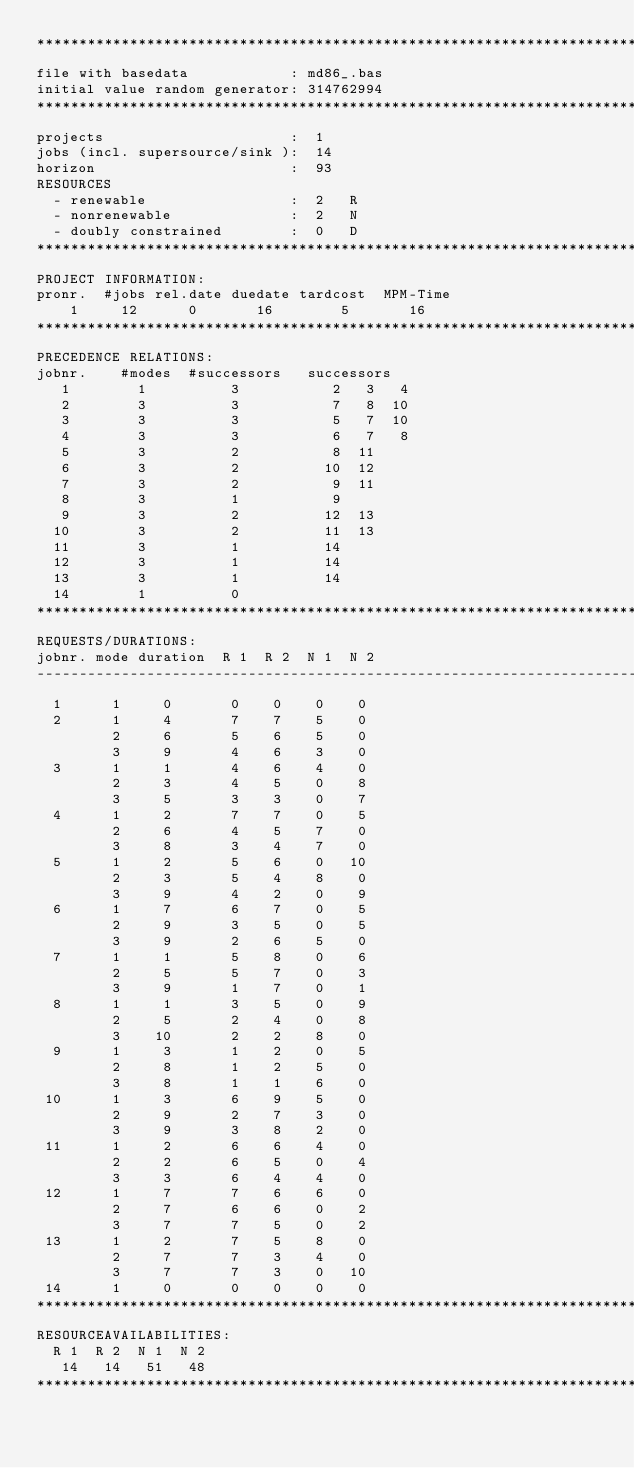Convert code to text. <code><loc_0><loc_0><loc_500><loc_500><_ObjectiveC_>************************************************************************
file with basedata            : md86_.bas
initial value random generator: 314762994
************************************************************************
projects                      :  1
jobs (incl. supersource/sink ):  14
horizon                       :  93
RESOURCES
  - renewable                 :  2   R
  - nonrenewable              :  2   N
  - doubly constrained        :  0   D
************************************************************************
PROJECT INFORMATION:
pronr.  #jobs rel.date duedate tardcost  MPM-Time
    1     12      0       16        5       16
************************************************************************
PRECEDENCE RELATIONS:
jobnr.    #modes  #successors   successors
   1        1          3           2   3   4
   2        3          3           7   8  10
   3        3          3           5   7  10
   4        3          3           6   7   8
   5        3          2           8  11
   6        3          2          10  12
   7        3          2           9  11
   8        3          1           9
   9        3          2          12  13
  10        3          2          11  13
  11        3          1          14
  12        3          1          14
  13        3          1          14
  14        1          0        
************************************************************************
REQUESTS/DURATIONS:
jobnr. mode duration  R 1  R 2  N 1  N 2
------------------------------------------------------------------------
  1      1     0       0    0    0    0
  2      1     4       7    7    5    0
         2     6       5    6    5    0
         3     9       4    6    3    0
  3      1     1       4    6    4    0
         2     3       4    5    0    8
         3     5       3    3    0    7
  4      1     2       7    7    0    5
         2     6       4    5    7    0
         3     8       3    4    7    0
  5      1     2       5    6    0   10
         2     3       5    4    8    0
         3     9       4    2    0    9
  6      1     7       6    7    0    5
         2     9       3    5    0    5
         3     9       2    6    5    0
  7      1     1       5    8    0    6
         2     5       5    7    0    3
         3     9       1    7    0    1
  8      1     1       3    5    0    9
         2     5       2    4    0    8
         3    10       2    2    8    0
  9      1     3       1    2    0    5
         2     8       1    2    5    0
         3     8       1    1    6    0
 10      1     3       6    9    5    0
         2     9       2    7    3    0
         3     9       3    8    2    0
 11      1     2       6    6    4    0
         2     2       6    5    0    4
         3     3       6    4    4    0
 12      1     7       7    6    6    0
         2     7       6    6    0    2
         3     7       7    5    0    2
 13      1     2       7    5    8    0
         2     7       7    3    4    0
         3     7       7    3    0   10
 14      1     0       0    0    0    0
************************************************************************
RESOURCEAVAILABILITIES:
  R 1  R 2  N 1  N 2
   14   14   51   48
************************************************************************
</code> 